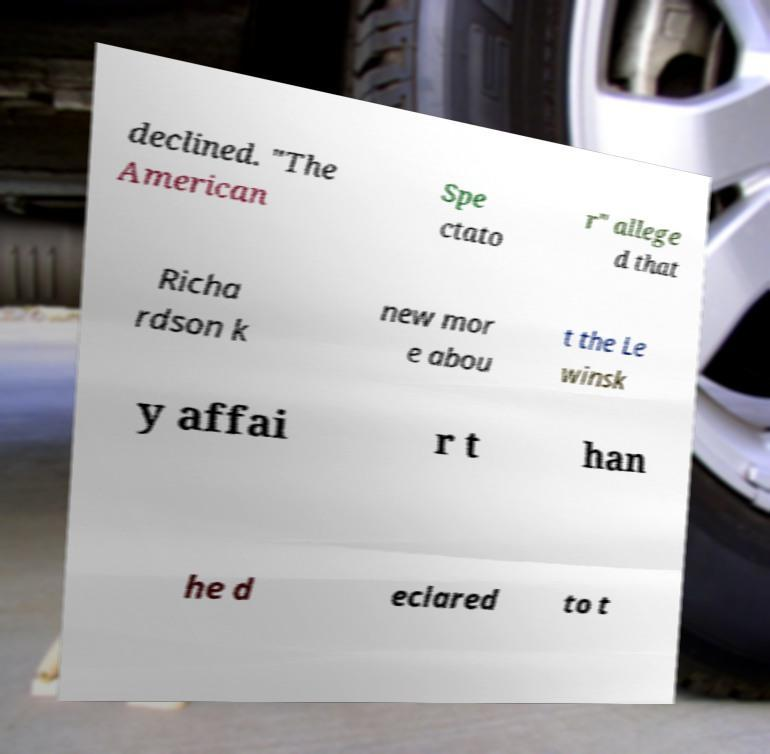Can you accurately transcribe the text from the provided image for me? declined. "The American Spe ctato r" allege d that Richa rdson k new mor e abou t the Le winsk y affai r t han he d eclared to t 